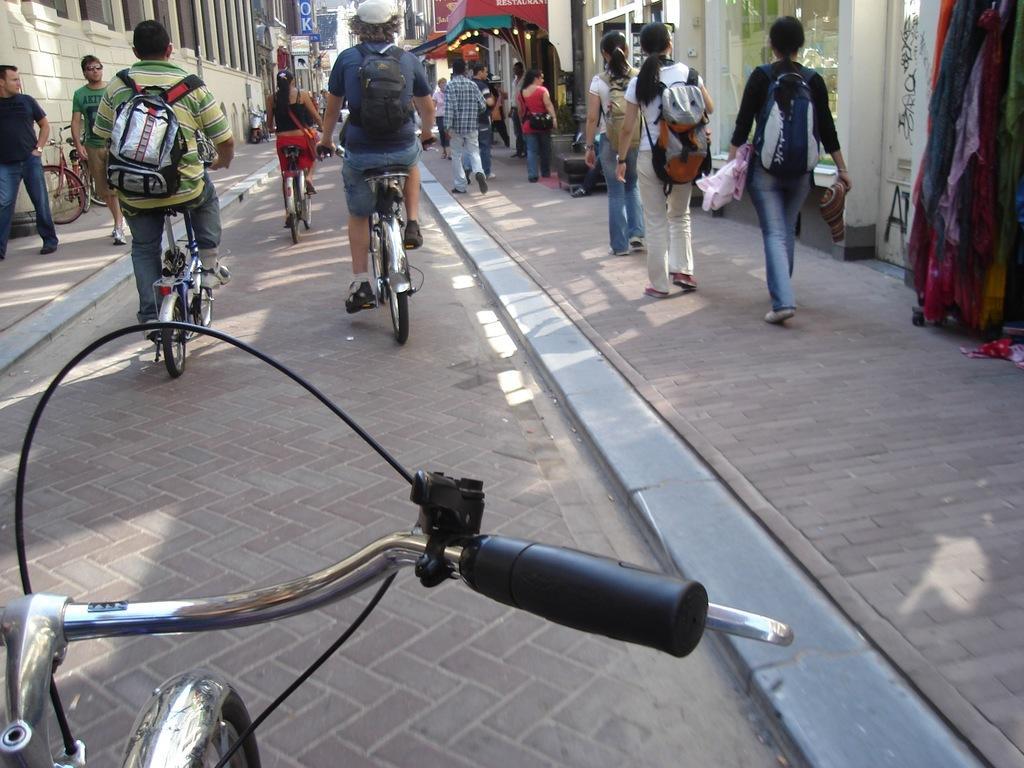Can you describe this image briefly? In this picture, it seems to be a street view where, the people they are walking on the foot path and there are some people they are cycling on the road side, there are some buildings at the left side of the image. 